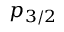<formula> <loc_0><loc_0><loc_500><loc_500>p _ { 3 / 2 }</formula> 